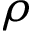Convert formula to latex. <formula><loc_0><loc_0><loc_500><loc_500>\rho</formula> 